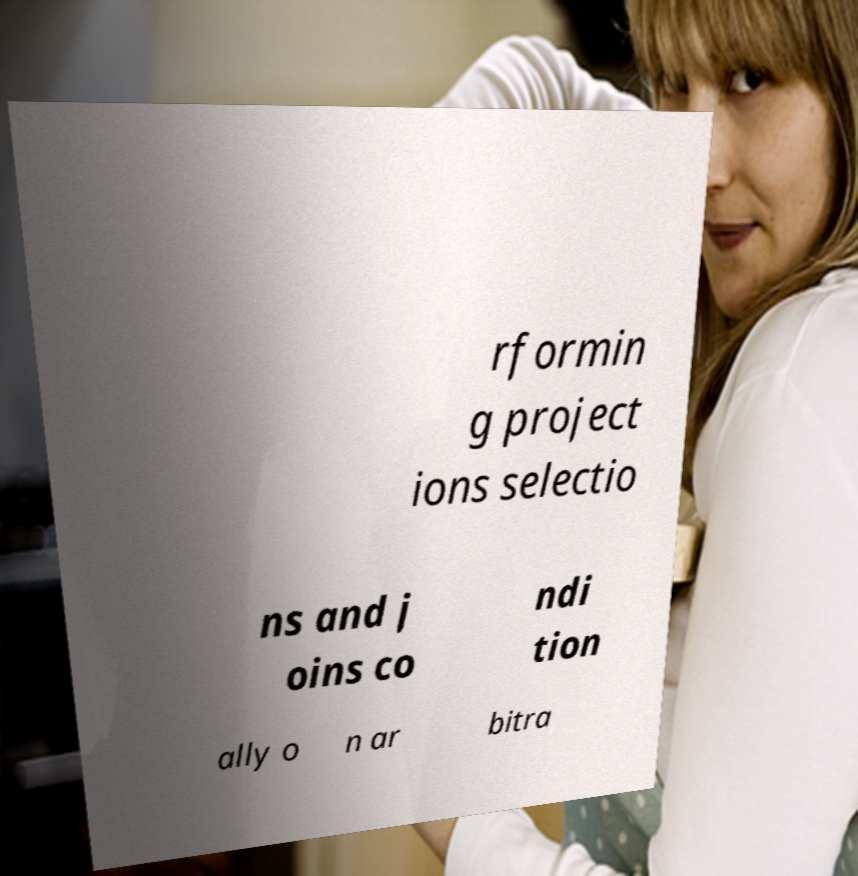Can you read and provide the text displayed in the image?This photo seems to have some interesting text. Can you extract and type it out for me? rformin g project ions selectio ns and j oins co ndi tion ally o n ar bitra 